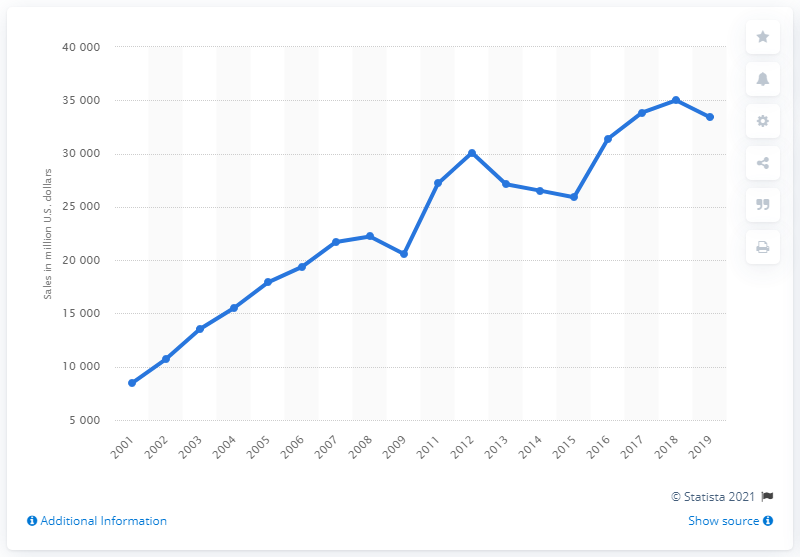Specify some key components in this picture. Aisin Seiki Co.'s global sales in 2019 were approximately 33,404 dollars. Aisin Seiki Co. began selling automotive parts in 2001. 